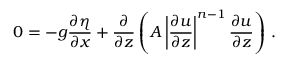Convert formula to latex. <formula><loc_0><loc_0><loc_500><loc_500>0 = - g \frac { \partial \eta } { \partial x } + \frac { \partial } { \partial z } \left ( A \left | \frac { \partial u } { \partial z } \right | ^ { n - 1 } \frac { \partial u } { \partial z } \right ) \, .</formula> 